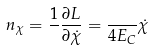Convert formula to latex. <formula><loc_0><loc_0><loc_500><loc_500>n _ { \chi } = \frac { 1 } { } \frac { \partial L } { \partial \dot { \chi } } = \frac { } { 4 E _ { C } } \dot { \chi }</formula> 